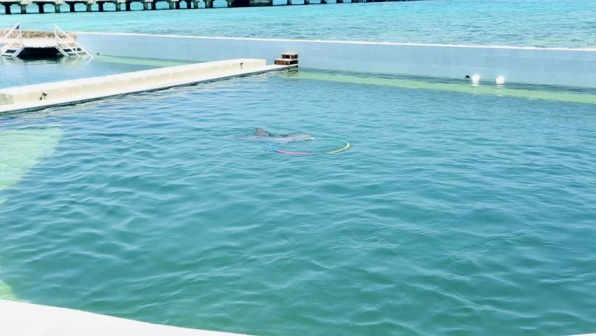If this place could speak, what story would it tell? If this place could speak, it would tell a story of harmony between humans and marine life. It would recount the daily activities of the dolphins, their playful antics, and their interactions with trainers and visitors. The place would share how it provides a safe haven for the dolphins, offering them care, companionship, and mental stimulation. The stories would include the excitement of visitors witnessing the dolphins' intelligence and agility, and the quiet moments when the water is still and the dolphins rest. It would speak of the dedication of the staff who maintain the facilities, ensuring that the aquatic inhabitants thrive. Overall, the story would be one of gentleness, care, and mutual respect between species. 